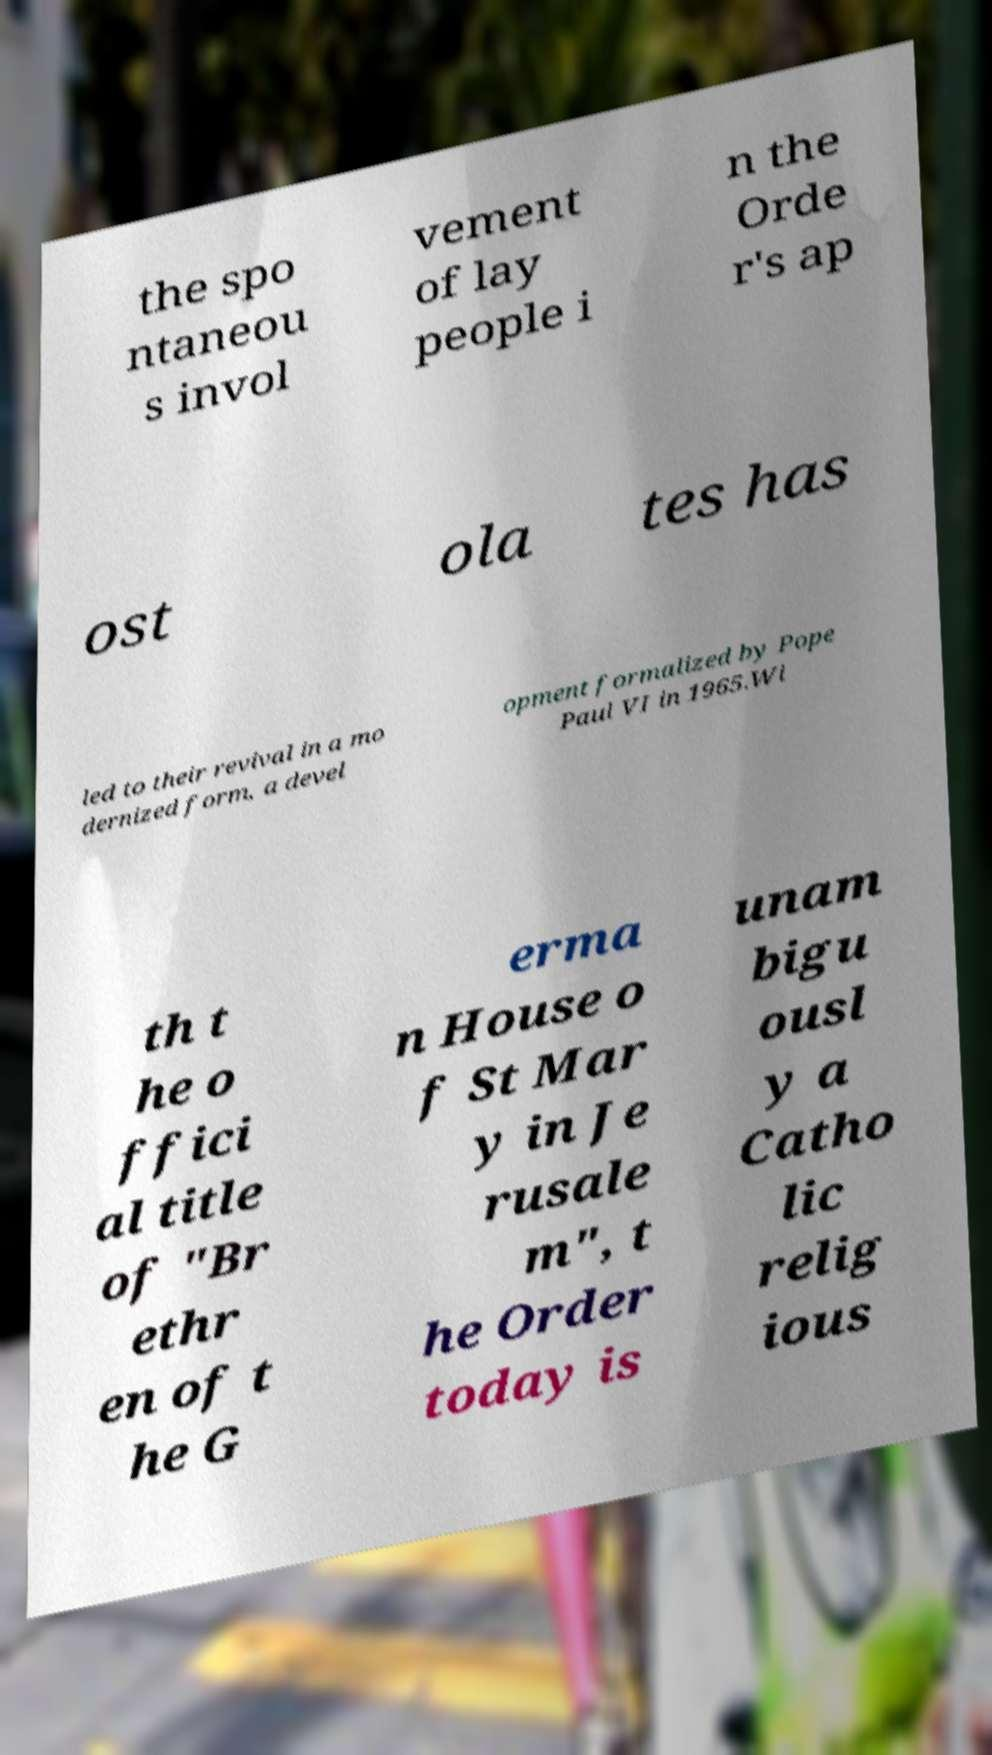Could you assist in decoding the text presented in this image and type it out clearly? the spo ntaneou s invol vement of lay people i n the Orde r's ap ost ola tes has led to their revival in a mo dernized form, a devel opment formalized by Pope Paul VI in 1965.Wi th t he o ffici al title of "Br ethr en of t he G erma n House o f St Mar y in Je rusale m", t he Order today is unam bigu ousl y a Catho lic relig ious 